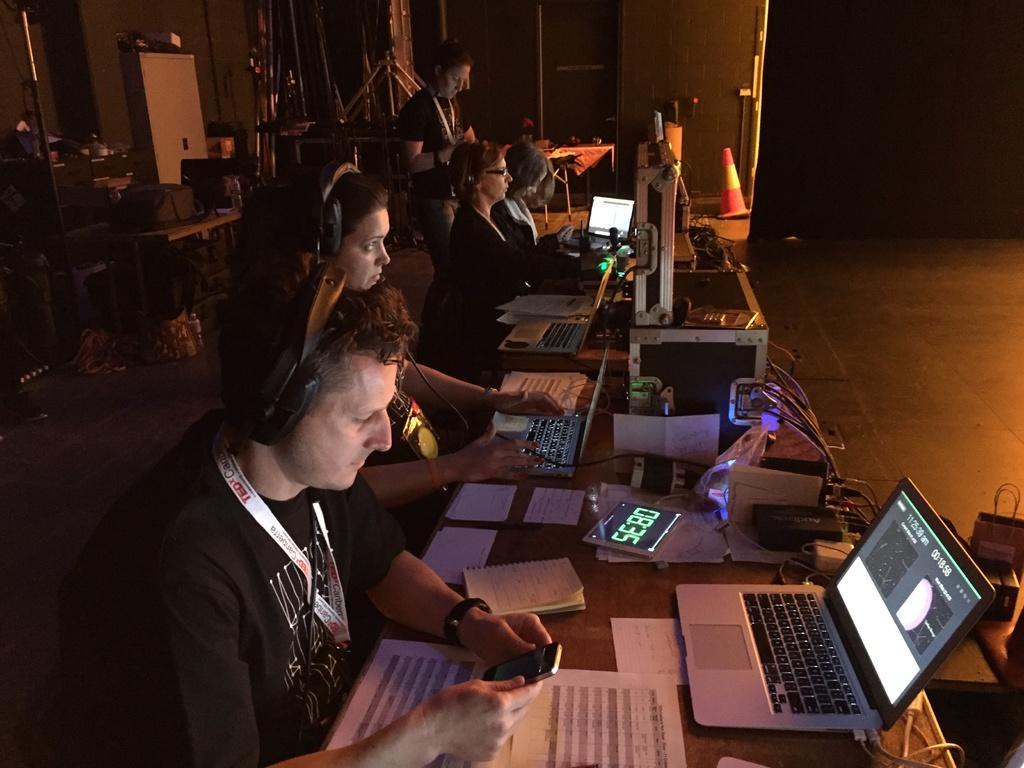In one or two sentences, can you explain what this image depicts? In this image I can see people operating laptops. There are papers, laptops, digital clock and a traffic cone at the back. 